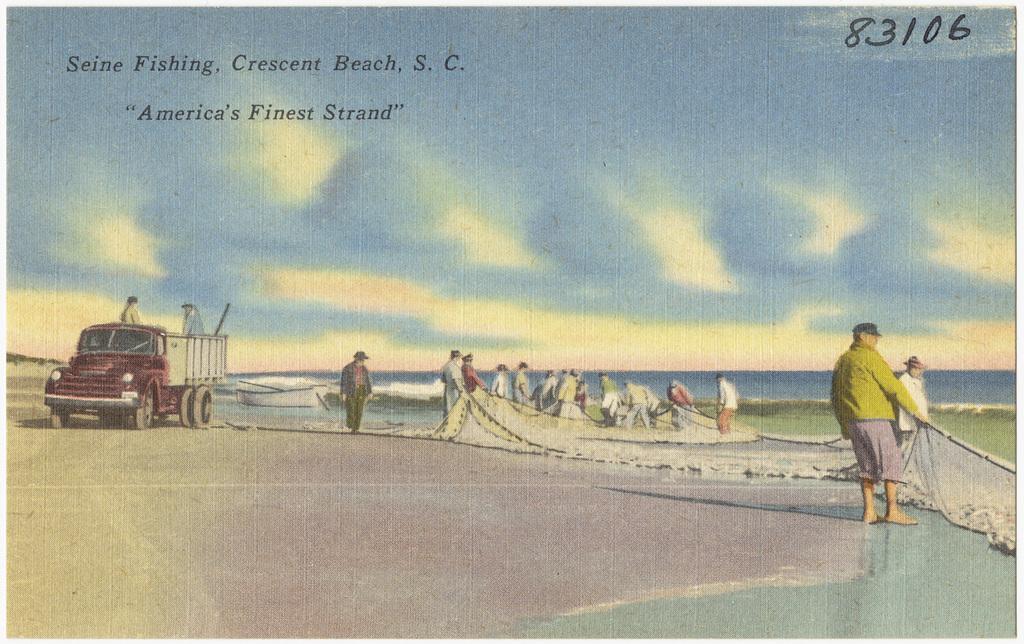Describe this image in one or two sentences. In this picture, we can see a poster of a few people on the ground holding objects, a few on the vehicle, we can see vehicle, ground, water and the sky, and we can see some text on the top side of the picture. 